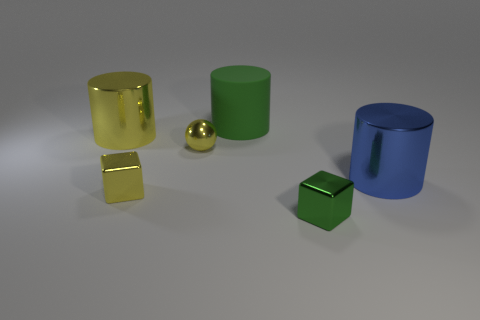Does the large metallic thing that is left of the green rubber thing have the same color as the big rubber object?
Give a very brief answer. No. How many green things are large cylinders or small metallic spheres?
Give a very brief answer. 1. Are there any other things that have the same material as the tiny yellow sphere?
Your answer should be very brief. Yes. Do the large thing that is in front of the big yellow object and the green block have the same material?
Provide a succinct answer. Yes. How many things are either green metallic blocks or small cubes that are on the right side of the large matte cylinder?
Provide a succinct answer. 1. How many yellow things are on the right side of the big metallic cylinder in front of the cylinder that is to the left of the tiny yellow cube?
Keep it short and to the point. 0. Do the large shiny object that is right of the tiny green shiny object and the small green object have the same shape?
Keep it short and to the point. No. Are there any tiny yellow objects that are on the right side of the big shiny object that is on the right side of the yellow metallic cube?
Keep it short and to the point. No. What number of big yellow shiny objects are there?
Your response must be concise. 1. The large object that is both in front of the big green rubber cylinder and right of the small yellow cube is what color?
Ensure brevity in your answer.  Blue. 